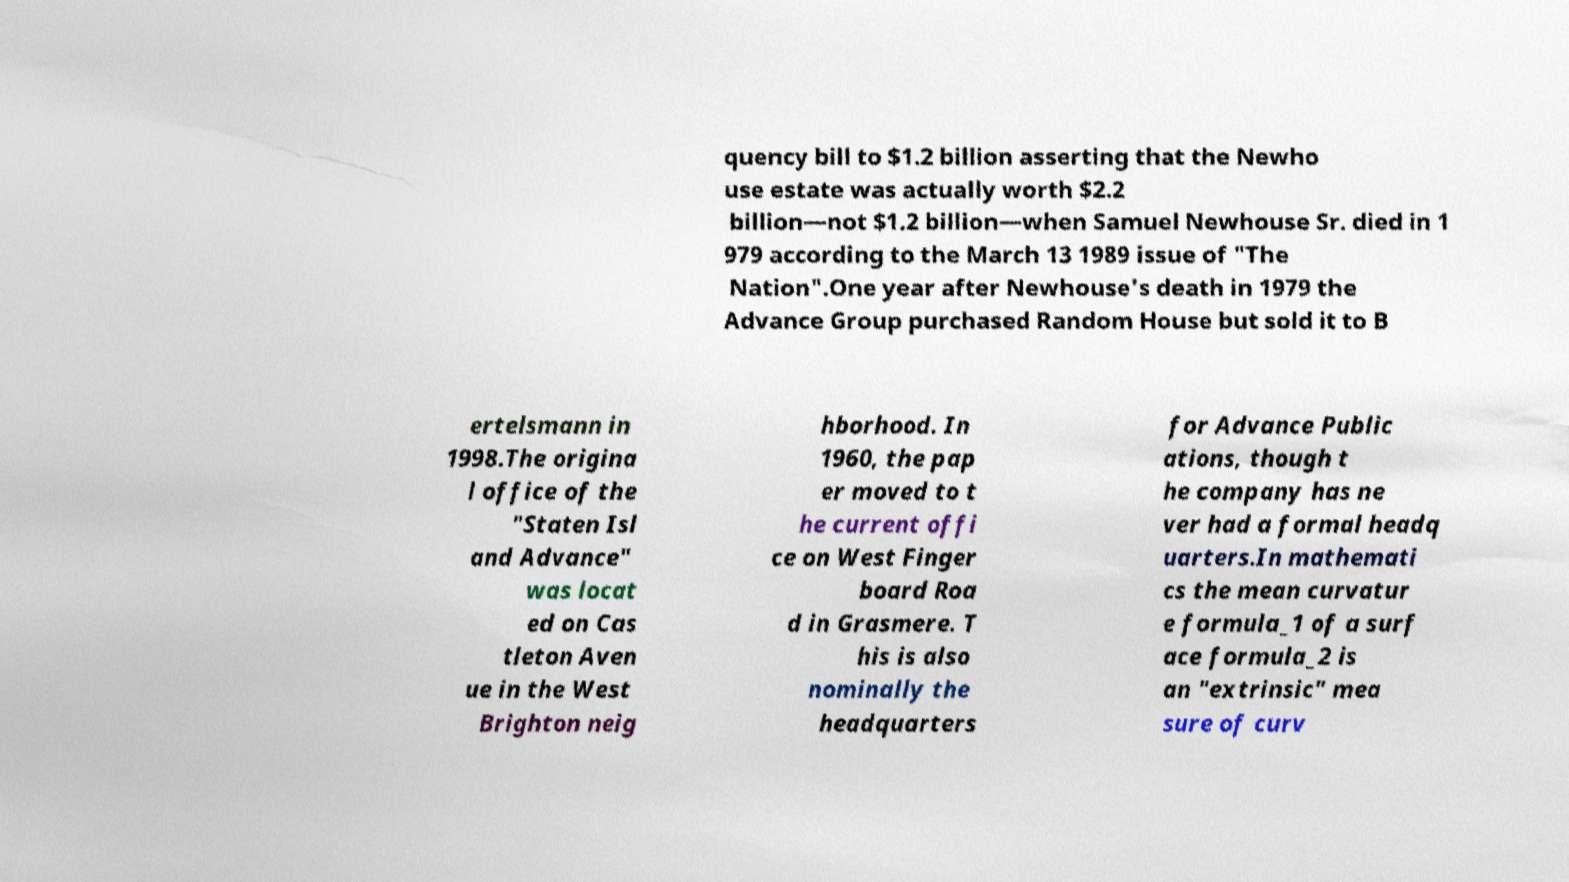Could you extract and type out the text from this image? quency bill to $1.2 billion asserting that the Newho use estate was actually worth $2.2 billion—not $1.2 billion—when Samuel Newhouse Sr. died in 1 979 according to the March 13 1989 issue of "The Nation".One year after Newhouse's death in 1979 the Advance Group purchased Random House but sold it to B ertelsmann in 1998.The origina l office of the "Staten Isl and Advance" was locat ed on Cas tleton Aven ue in the West Brighton neig hborhood. In 1960, the pap er moved to t he current offi ce on West Finger board Roa d in Grasmere. T his is also nominally the headquarters for Advance Public ations, though t he company has ne ver had a formal headq uarters.In mathemati cs the mean curvatur e formula_1 of a surf ace formula_2 is an "extrinsic" mea sure of curv 